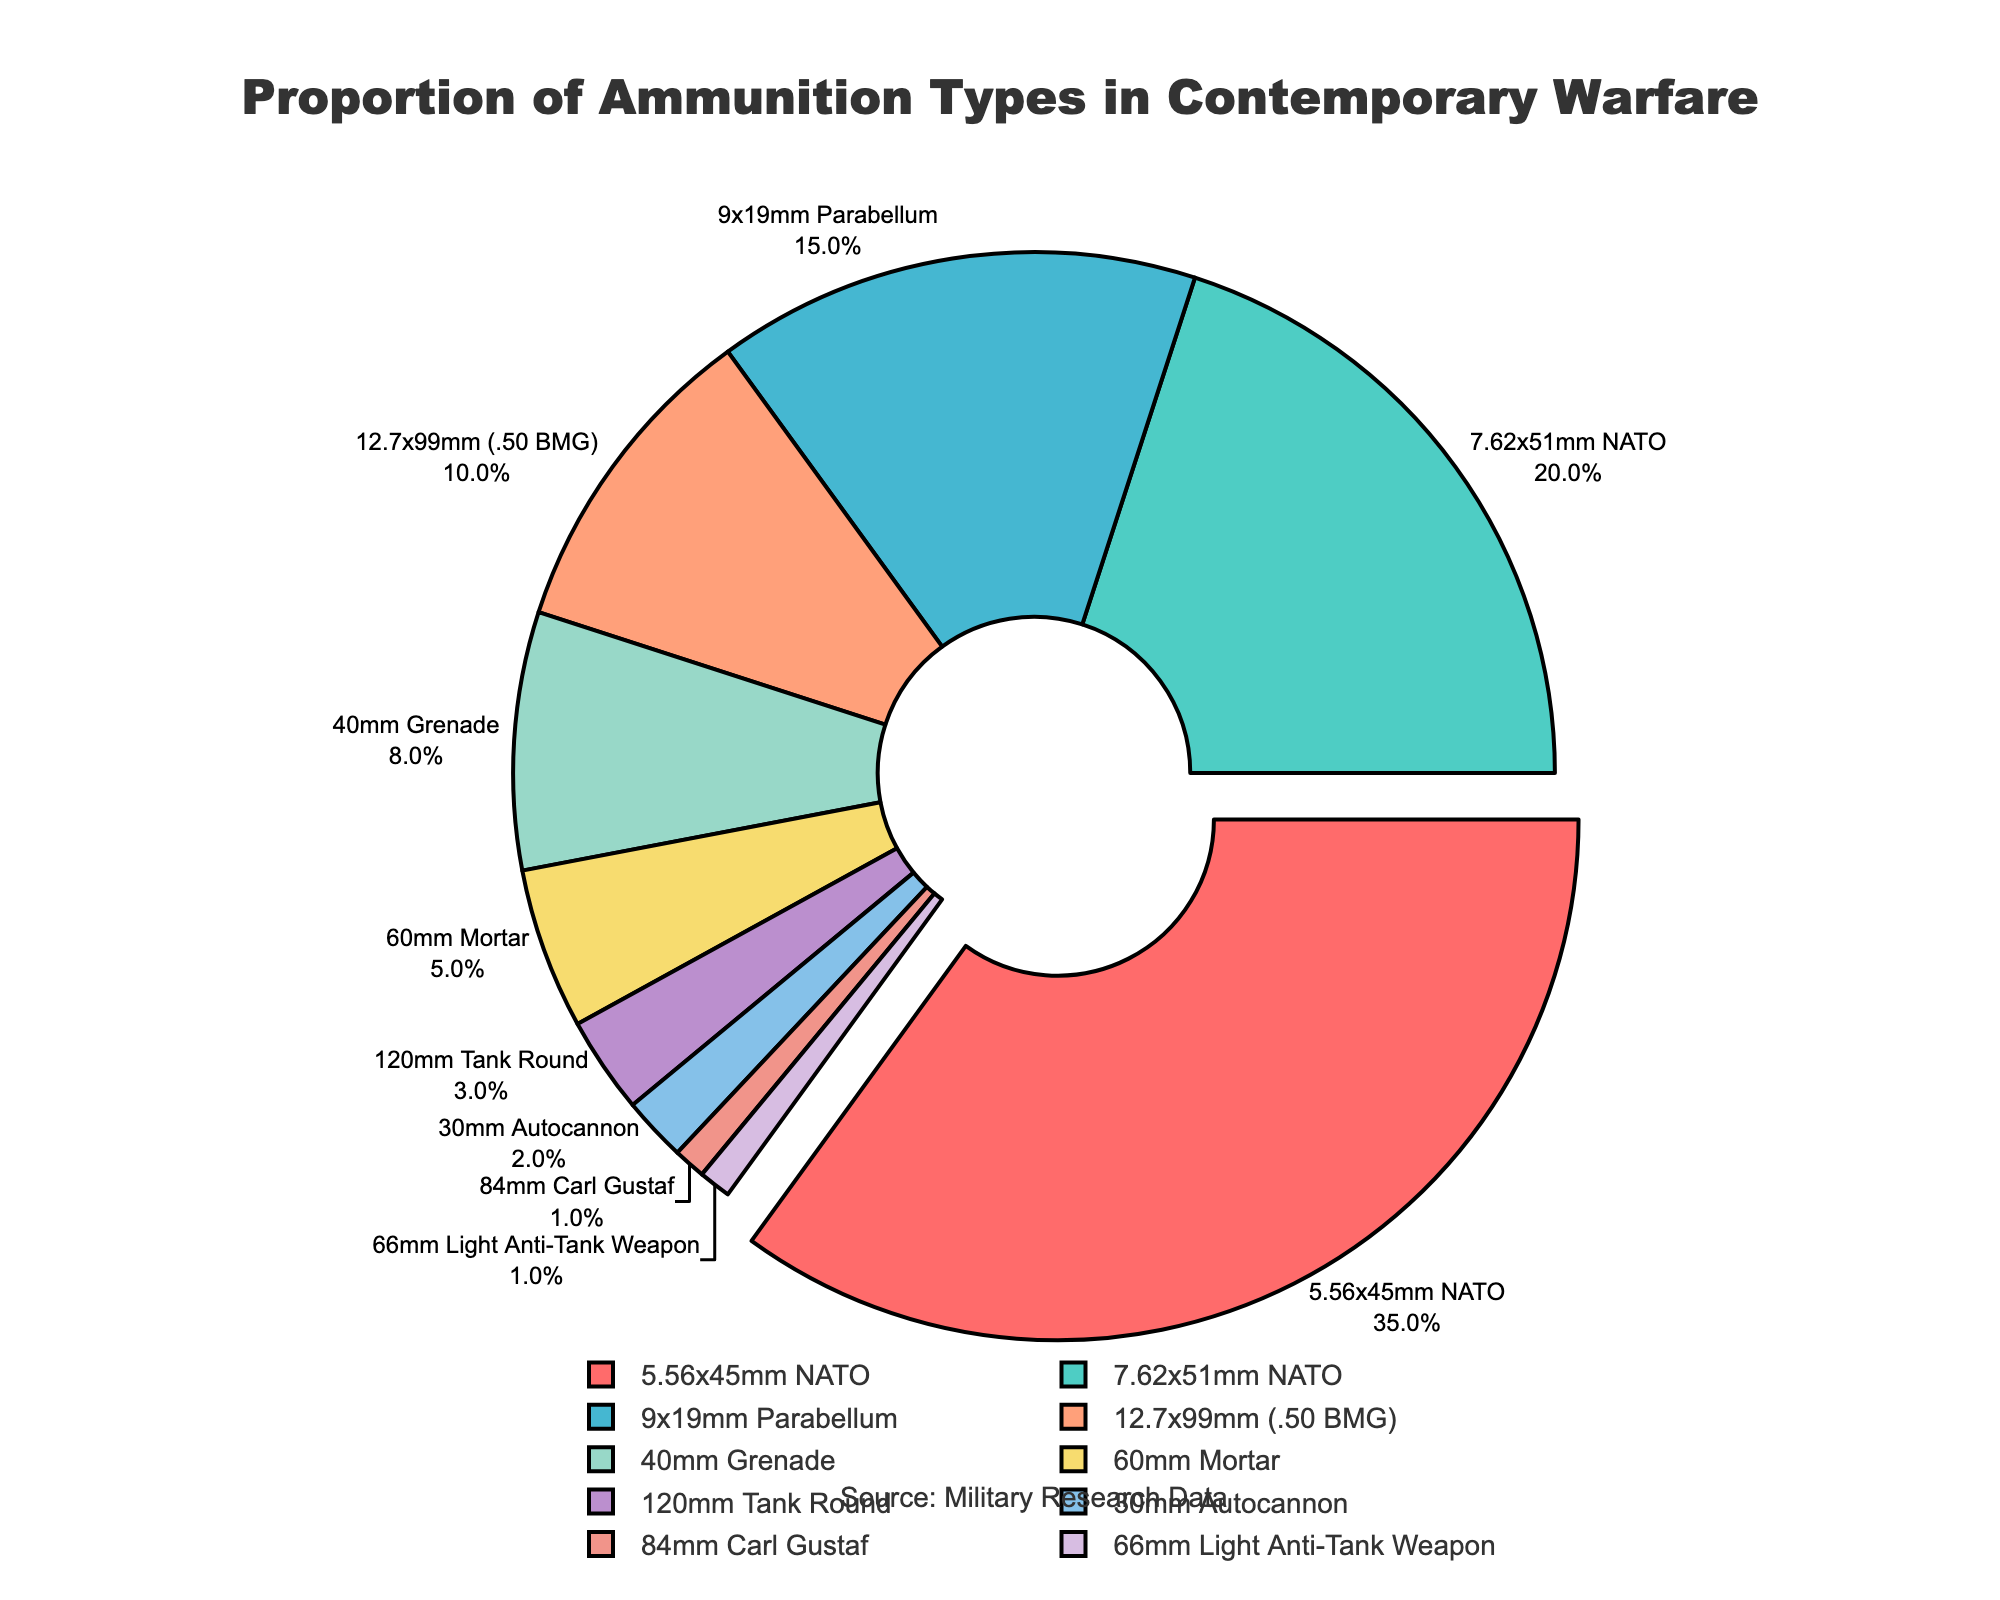What ammunition type constitutes the largest proportion in contemporary warfare? The pie chart shows the proportion of various ammunition types used in contemporary warfare. The 5.56x45mm NATO has the biggest slice.
Answer: 5.56x45mm NATO What is the combined percentage of 9x19mm Parabellum and 12.7x99mm (.50 BMG) ammunition types? The pie chart shows that 9x19mm Parabellum is 15% and 12.7x99mm (.50 BMG) is 10%. Adding these two proportions together gives 15% + 10% = 25%.
Answer: 25% Which ammunition types have a proportion less than 5% individually? On the pie chart, the ammunition types with proportions less than 5% are labeled: 120mm Tank Round (3%), 30mm Autocannon (2%), 84mm Carl Gustaf (1%), and 66mm Light Anti-Tank Weapon (1%).
Answer: 120mm Tank Round, 30mm Autocannon, 84mm Carl Gustaf, 66mm Light Anti-Tank Weapon How does the percentage of 7.62x51mm NATO compare to that of 40mm Grenade? By examining the pie chart, the percentage for 7.62x51mm NATO is 20%, which is greater than the 8% for 40mm Grenade.
Answer: Greater What is the total percentage of medium and large caliber ammunition (including 12.7x99mm, 60mm Mortar, and 120mm Tank Round) combined? From the pie chart, the percentages are: 12.7x99mm (.50 BMG) is 10%, 60mm Mortar is 5%, and 120mm Tank Round is 3%. Summing these gives 10% + 5% + 3% = 18%.
Answer: 18% Which ammunition type is presented in green color on the chart? Visual inspection of the pie chart reveals that 7.62x51mm NATO is represented by the green color.
Answer: 7.62x51mm NATO Is the percentage of 5.56x45mm NATO greater than the combined percentage of 40mm Grenade and 60mm Mortar? The pie chart shows that the 5.56x45mm NATO is 35%, while 40mm Grenade is 8% and 60mm Mortar is 5%. The combined percentage of 40mm Grenade and 60mm Mortar is 8% + 5% = 13%, which is less than 35%.
Answer: Yes, it is greater Which three ammunition types together make up over half of the total proportion? By looking at the pie chart, the percentages are: 5.56x45mm NATO is 35%, 7.62x51mm NATO is 20%, and 9x19mm Parabellum is 15%. Their combined percentage is 35% + 20% + 15% = 70%, which is more than 50%.
Answer: 5.56x45mm NATO, 7.62x51mm NATO, 9x19mm Parabellum What is the difference in percentage between 5.56x45mm NATO and 9x19mm Parabellum? The pie chart indicates that 5.56x45mm NATO is 35% and 9x19mm Parabellum is 15%. The difference is 35% - 15% = 20%.
Answer: 20% Considering small caliber ammunition types (5.56x45mm NATO, 7.62x51mm NATO, and 9x19mm Parabellum), what is their combined percentage? The pie chart shows the values as: 5.56x45mm NATO is 35%, 7.62x51mm NATO is 20%, and 9x19mm Parabellum is 15%. Their combined percentage is 35% + 20% + 15% = 70%.
Answer: 70% 